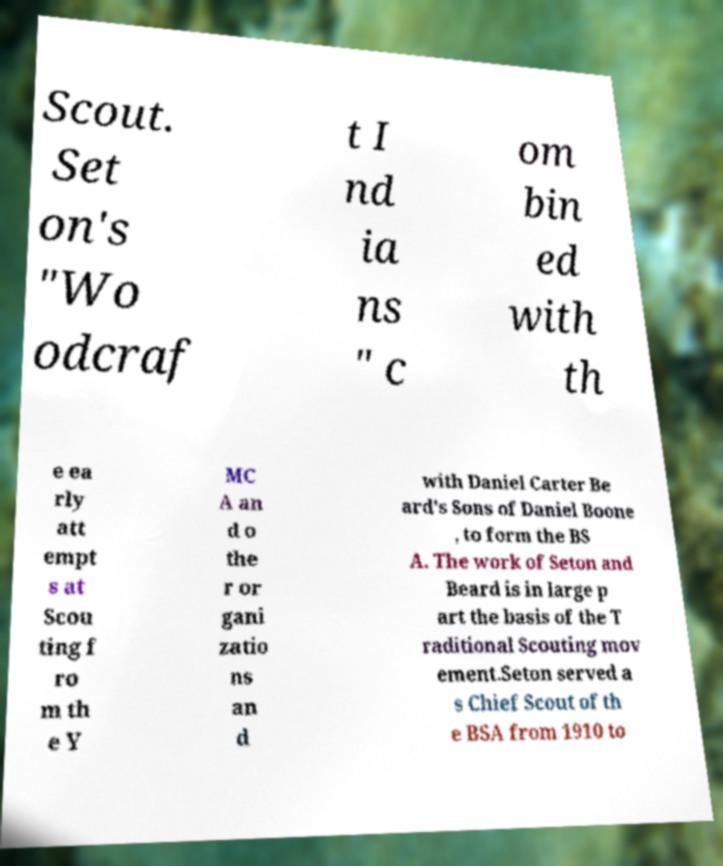There's text embedded in this image that I need extracted. Can you transcribe it verbatim? Scout. Set on's "Wo odcraf t I nd ia ns " c om bin ed with th e ea rly att empt s at Scou ting f ro m th e Y MC A an d o the r or gani zatio ns an d with Daniel Carter Be ard's Sons of Daniel Boone , to form the BS A. The work of Seton and Beard is in large p art the basis of the T raditional Scouting mov ement.Seton served a s Chief Scout of th e BSA from 1910 to 